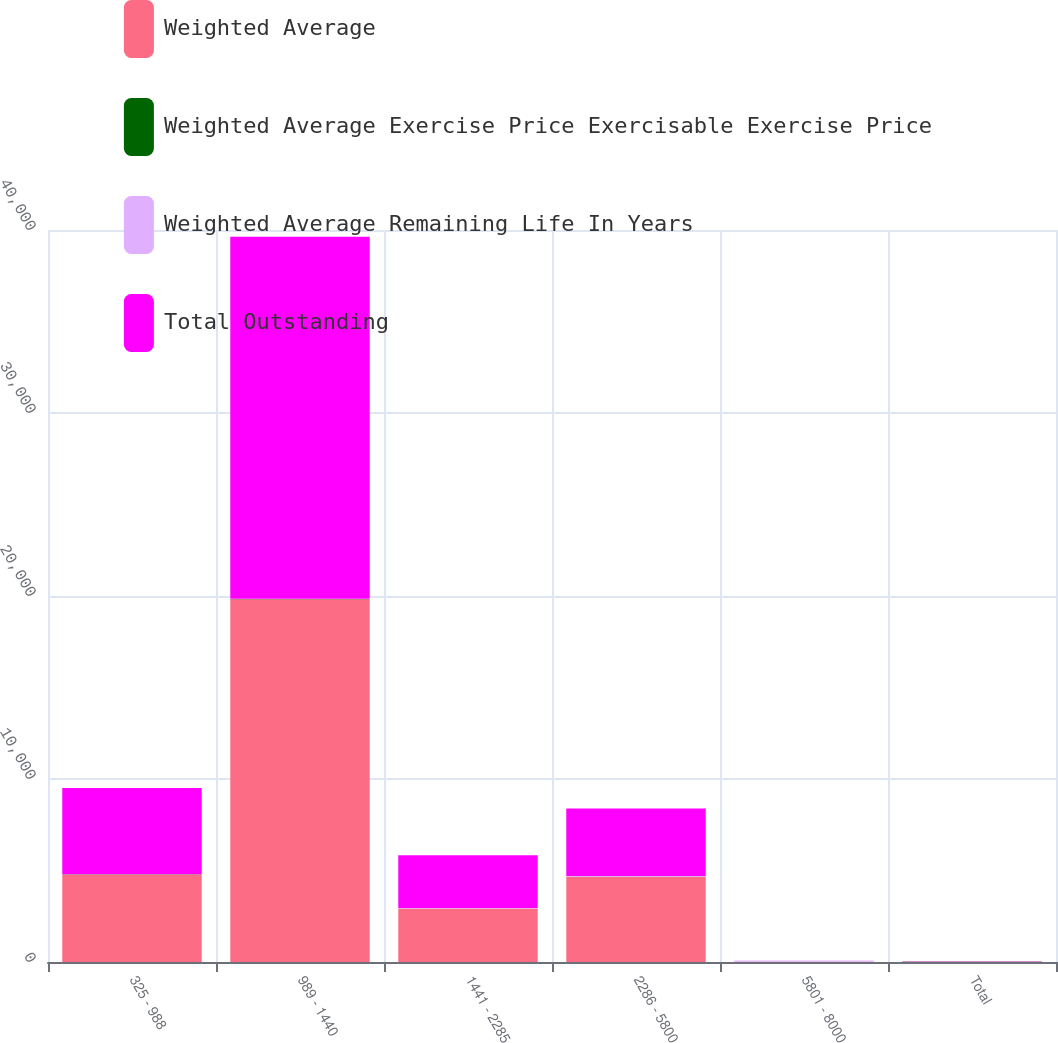<chart> <loc_0><loc_0><loc_500><loc_500><stacked_bar_chart><ecel><fcel>325 - 988<fcel>989 - 1440<fcel>1441 - 2285<fcel>2286 - 5800<fcel>5801 - 8000<fcel>Total<nl><fcel>Weighted Average<fcel>4787<fcel>19828<fcel>2924<fcel>4648<fcel>9<fcel>17.11<nl><fcel>Weighted Average Exercise Price Exercisable Exercise Price<fcel>2.5<fcel>8.4<fcel>5.7<fcel>7.4<fcel>7.7<fcel>7.2<nl><fcel>Weighted Average Remaining Life In Years<fcel>5.39<fcel>13.03<fcel>17.85<fcel>44.11<fcel>61.42<fcel>16.37<nl><fcel>Total Outstanding<fcel>4707<fcel>19775<fcel>2884<fcel>3683<fcel>8<fcel>17.11<nl></chart> 